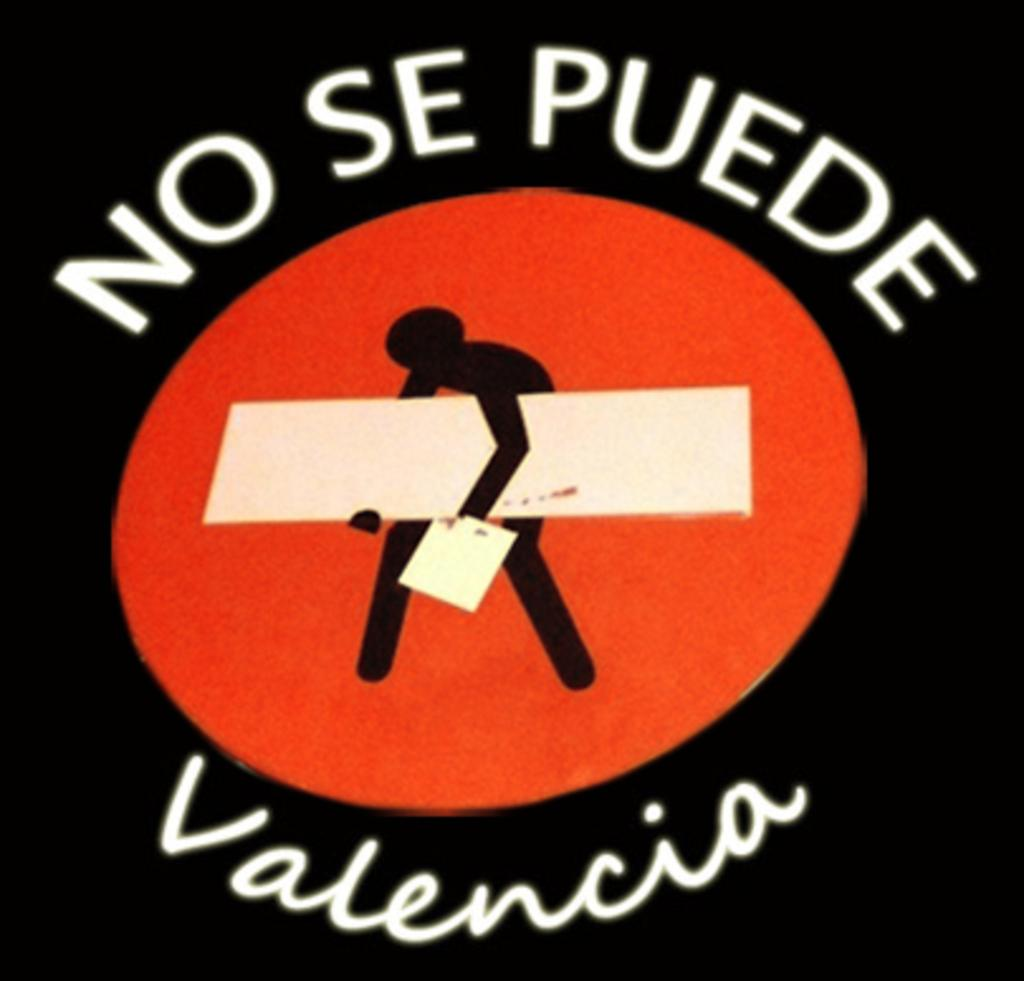<image>
Relay a brief, clear account of the picture shown. A sign with a person hunched over carrying a plank reads No Se Puede Valencia. 